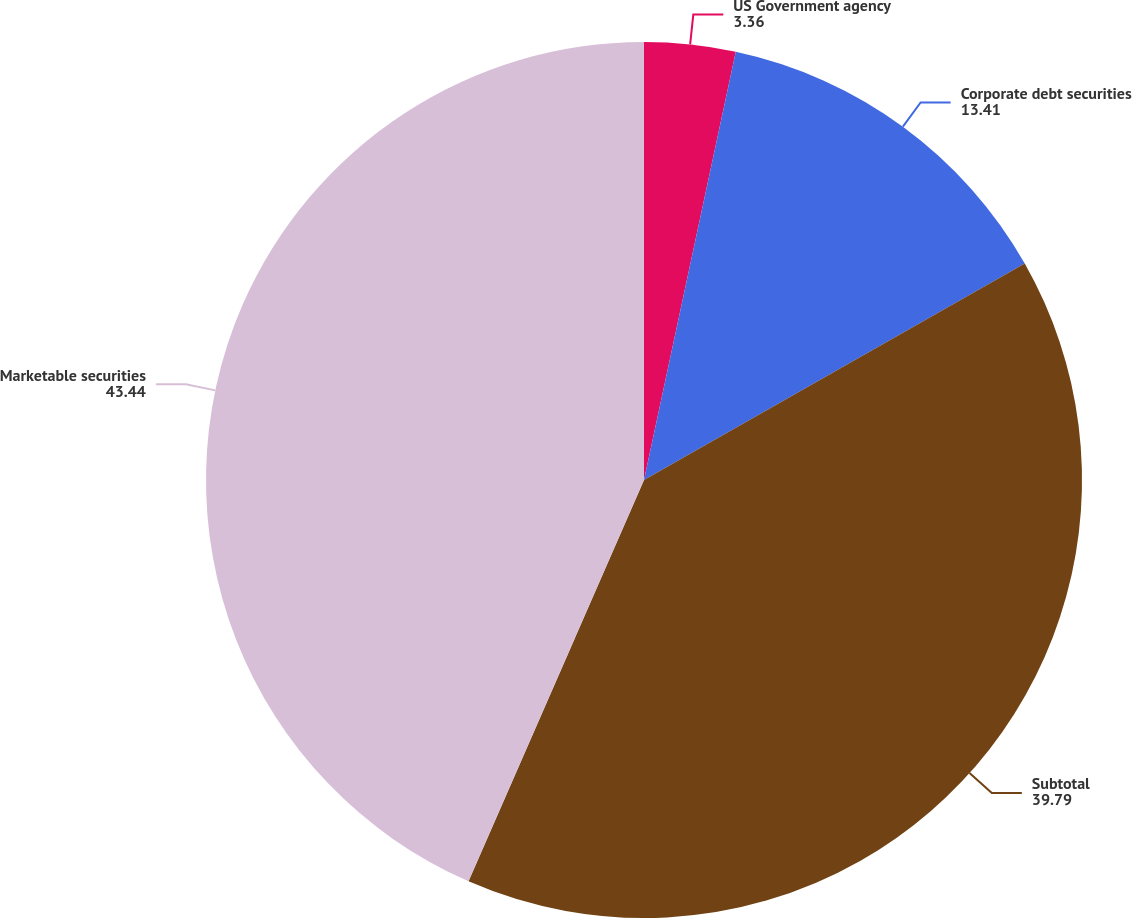Convert chart. <chart><loc_0><loc_0><loc_500><loc_500><pie_chart><fcel>US Government agency<fcel>Corporate debt securities<fcel>Subtotal<fcel>Marketable securities<nl><fcel>3.36%<fcel>13.41%<fcel>39.79%<fcel>43.44%<nl></chart> 